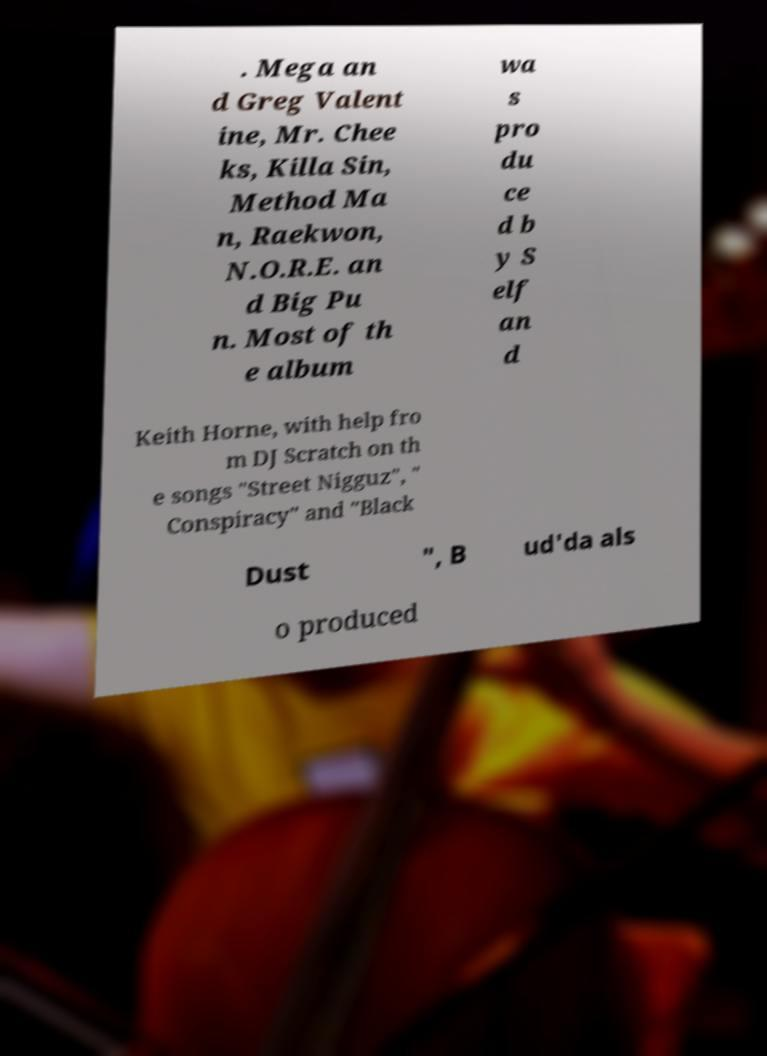Can you accurately transcribe the text from the provided image for me? . Mega an d Greg Valent ine, Mr. Chee ks, Killa Sin, Method Ma n, Raekwon, N.O.R.E. an d Big Pu n. Most of th e album wa s pro du ce d b y S elf an d Keith Horne, with help fro m DJ Scratch on th e songs "Street Nigguz", " Conspiracy" and "Black Dust ", B ud'da als o produced 